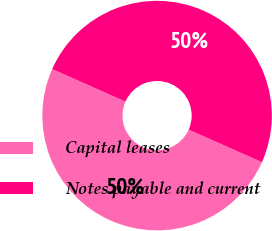Convert chart to OTSL. <chart><loc_0><loc_0><loc_500><loc_500><pie_chart><fcel>Capital leases<fcel>Notes payable and current<nl><fcel>49.99%<fcel>50.01%<nl></chart> 